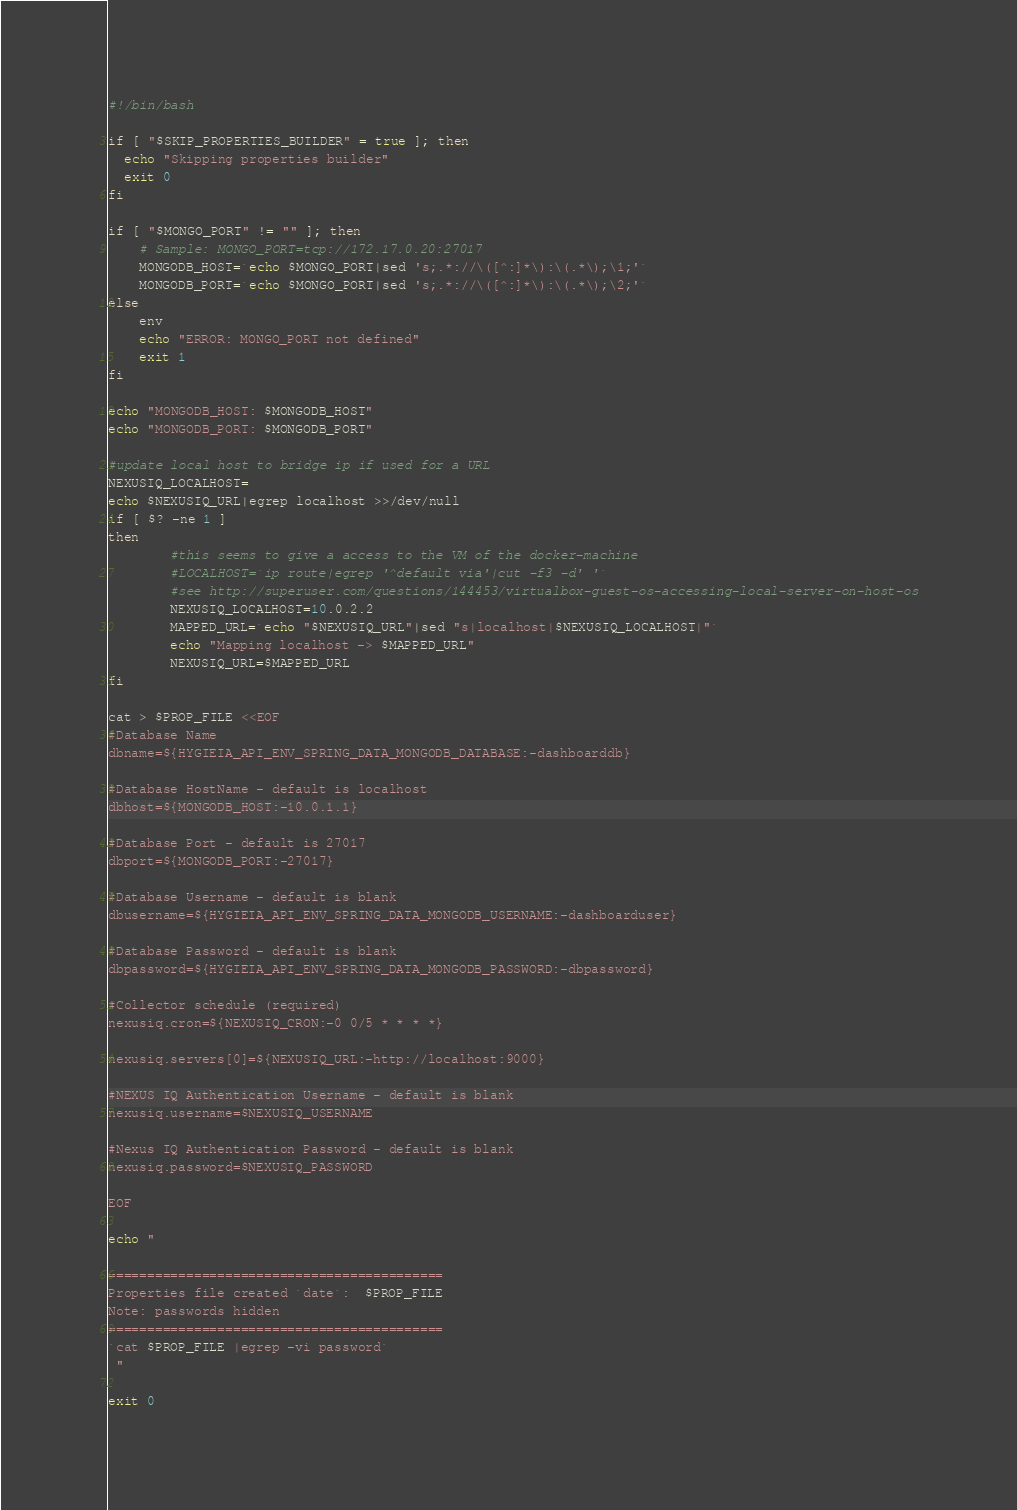Convert code to text. <code><loc_0><loc_0><loc_500><loc_500><_Bash_>#!/bin/bash

if [ "$SKIP_PROPERTIES_BUILDER" = true ]; then
  echo "Skipping properties builder"
  exit 0
fi

if [ "$MONGO_PORT" != "" ]; then
	# Sample: MONGO_PORT=tcp://172.17.0.20:27017
	MONGODB_HOST=`echo $MONGO_PORT|sed 's;.*://\([^:]*\):\(.*\);\1;'`
	MONGODB_PORT=`echo $MONGO_PORT|sed 's;.*://\([^:]*\):\(.*\);\2;'`
else
	env
	echo "ERROR: MONGO_PORT not defined"
	exit 1
fi

echo "MONGODB_HOST: $MONGODB_HOST"
echo "MONGODB_PORT: $MONGODB_PORT"

#update local host to bridge ip if used for a URL
NEXUSIQ_LOCALHOST=
echo $NEXUSIQ_URL|egrep localhost >>/dev/null
if [ $? -ne 1 ]
then
        #this seems to give a access to the VM of the docker-machine
        #LOCALHOST=`ip route|egrep '^default via'|cut -f3 -d' '`
        #see http://superuser.com/questions/144453/virtualbox-guest-os-accessing-local-server-on-host-os
        NEXUSIQ_LOCALHOST=10.0.2.2
        MAPPED_URL=`echo "$NEXUSIQ_URL"|sed "s|localhost|$NEXUSIQ_LOCALHOST|"`
        echo "Mapping localhost -> $MAPPED_URL"
        NEXUSIQ_URL=$MAPPED_URL
fi

cat > $PROP_FILE <<EOF
#Database Name
dbname=${HYGIEIA_API_ENV_SPRING_DATA_MONGODB_DATABASE:-dashboarddb}

#Database HostName - default is localhost
dbhost=${MONGODB_HOST:-10.0.1.1}

#Database Port - default is 27017
dbport=${MONGODB_PORT:-27017}

#Database Username - default is blank
dbusername=${HYGIEIA_API_ENV_SPRING_DATA_MONGODB_USERNAME:-dashboarduser}

#Database Password - default is blank
dbpassword=${HYGIEIA_API_ENV_SPRING_DATA_MONGODB_PASSWORD:-dbpassword}

#Collector schedule (required)
nexusiq.cron=${NEXUSIQ_CRON:-0 0/5 * * * *}

nexusiq.servers[0]=${NEXUSIQ_URL:-http://localhost:9000}

#NEXUS IQ Authentication Username - default is blank
nexusiq.username=$NEXUSIQ_USERNAME

#Nexus IQ Authentication Password - default is blank
nexusiq.password=$NEXUSIQ_PASSWORD

EOF

echo "

===========================================
Properties file created `date`:  $PROP_FILE
Note: passwords hidden
===========================================
`cat $PROP_FILE |egrep -vi password`
 "

exit 0
</code> 